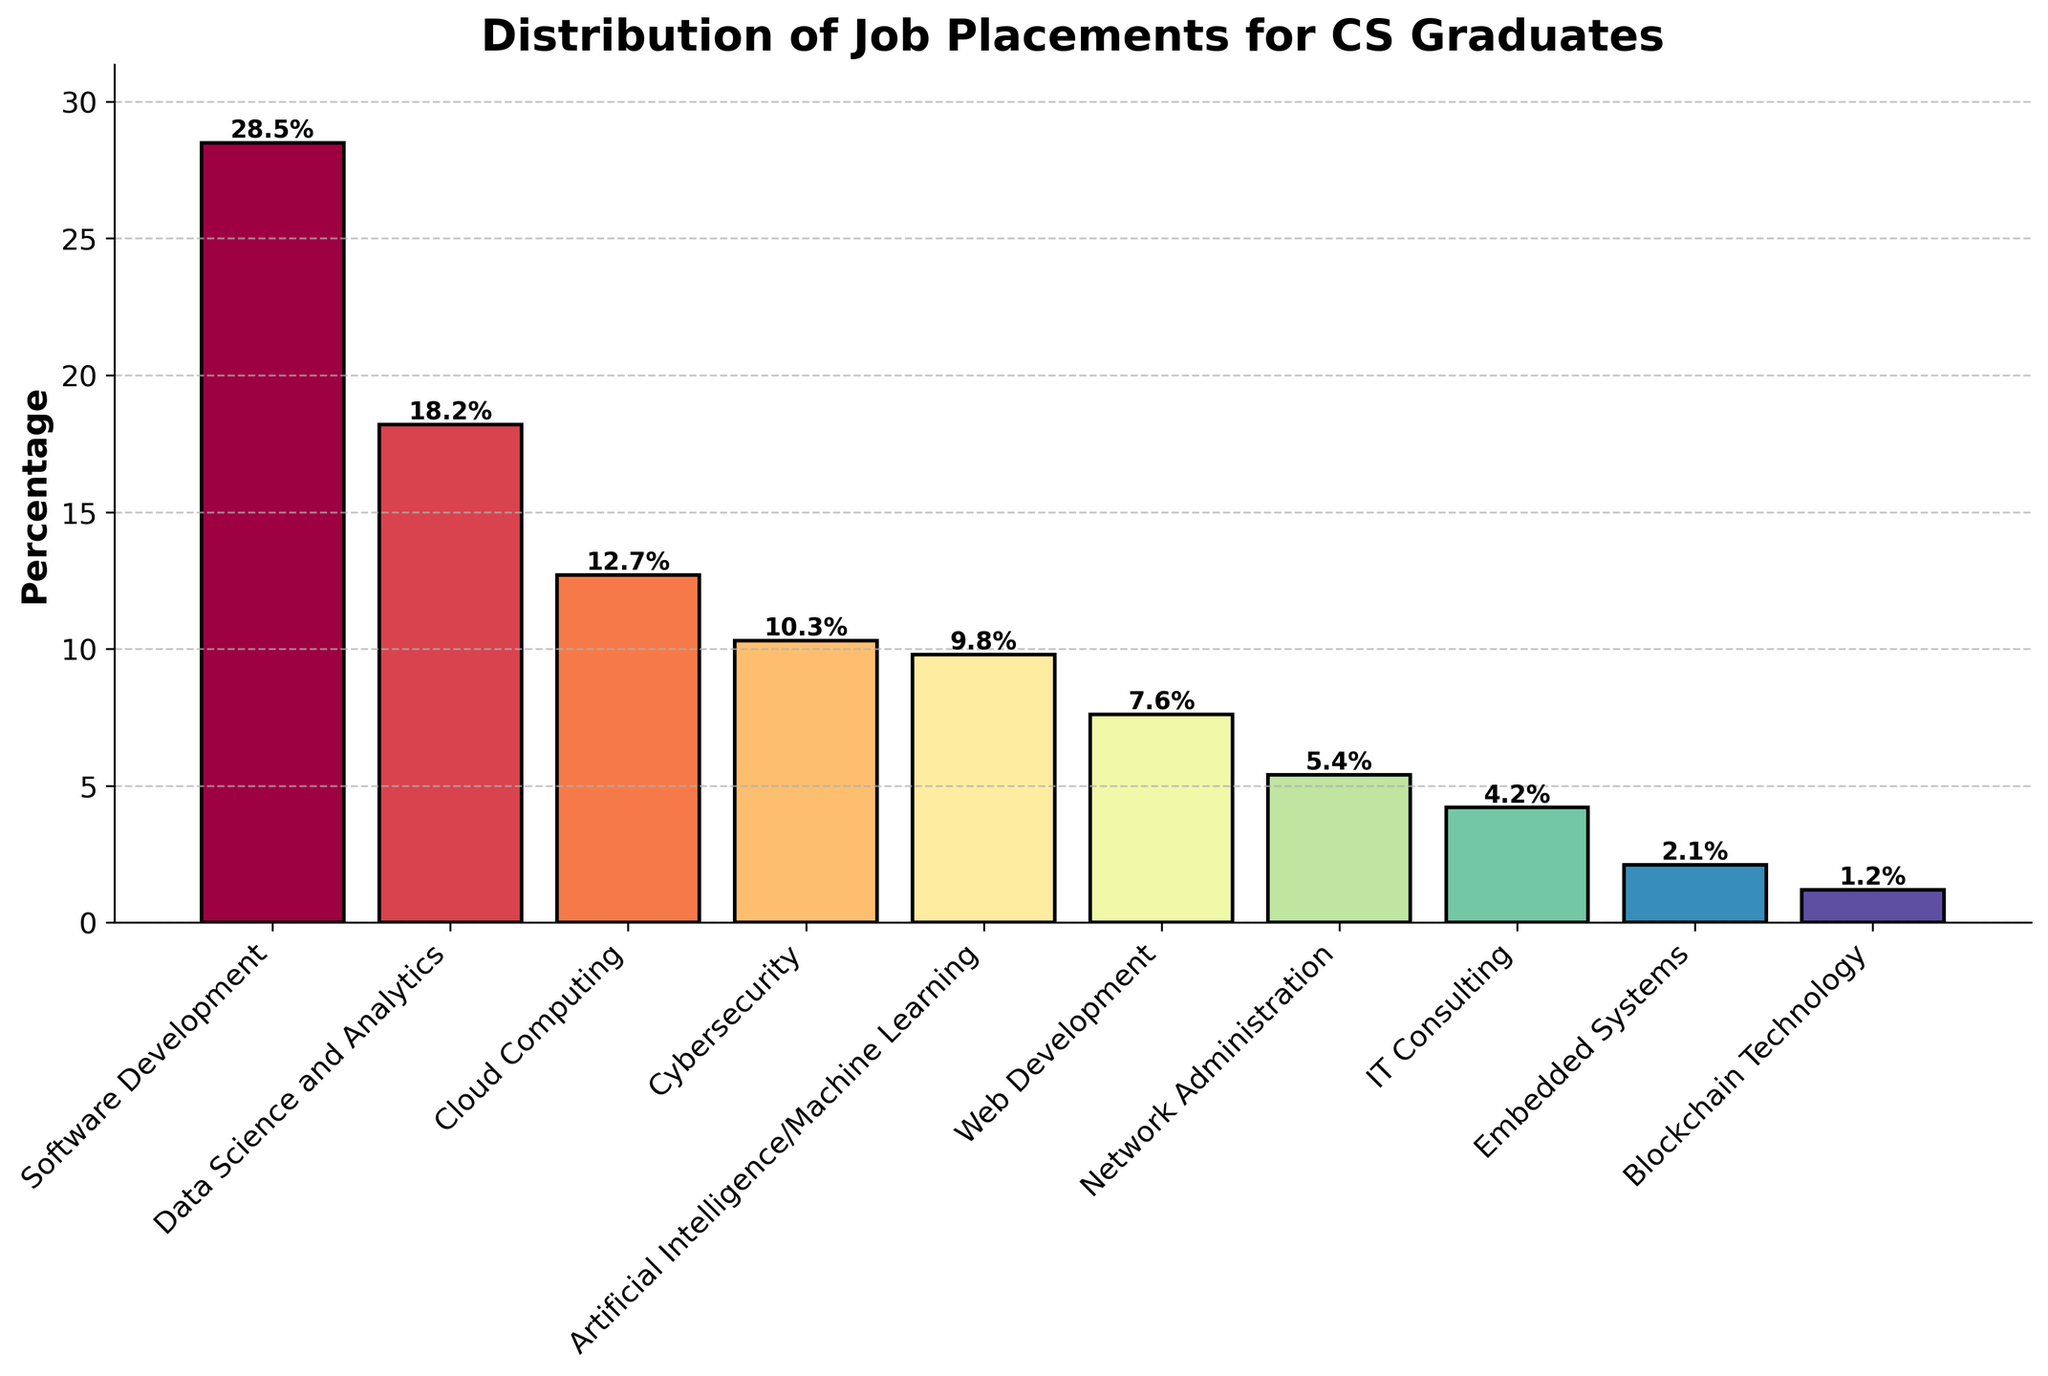What's the sector with the highest percentage of job placements? The sector with the highest percentage can be found by looking for the tallest bar in the chart. The tallest bar represents Software Development.
Answer: Software Development By how much does the percentage of job placements in Data Science and Analytics differ from that in Cloud Computing? The percentages of job placements in Data Science and Analytics and Cloud Computing are 18.2% and 12.7%, respectively. The difference can be calculated as 18.2% - 12.7% = 5.5%.
Answer: 5.5% Which sectors have a lower percentage of job placements than Web Development? Web Development has a percentage of 7.6%. We look for sectors with bars shorter than this: Network Administration (5.4%), IT Consulting (4.2%), Embedded Systems (2.1%), and Blockchain Technology (1.2%).
Answer: Network Administration, IT Consulting, Embedded Systems, Blockchain Technology What's the combined percentage of job placements for Artificial Intelligence/Machine Learning and Cybersecurity? The percentages are 9.8% for Artificial Intelligence/Machine Learning and 10.3% for Cybersecurity. The combined percentage is 9.8% + 10.3% = 20.1%.
Answer: 20.1% Is the percentage of job placements in IT Consulting more or less than half of the percentage in Cybersecurity? The percentage in Cybersecurity is 10.3%. Half of this value is 10.3% / 2 = 5.15%. The percentage in IT Consulting is 4.2%, which is less than 5.15%.
Answer: Less than Which sectors show single-digit percentages of job placements? Sectors with single-digit percentages are displayed with bars that have heights between 0% and 9.9%. The sectors are Artificial Intelligence/Machine Learning (9.8%), Web Development (7.6%), Network Administration (5.4%), IT Consulting (4.2%), Embedded Systems (2.1%), and Blockchain Technology (1.2%).
Answer: Artificial Intelligence/Machine Learning, Web Development, Network Administration, IT Consulting, Embedded Systems, Blockchain Technology Among the job placement sectors, which has the shortest bar in the figure? The shortest bar represents the sector with the lowest percentage. This is Blockchain Technology with 1.2%.
Answer: Blockchain Technology How much higher is the percentage of job placements in Software Development compared to Cybersecurity? The percentages are 28.5% for Software Development and 10.3% for Cybersecurity. The difference is 28.5% - 10.3% = 18.2%.
Answer: 18.2% If the percentages are grouped in ranges of 10%, how many sectors fall into each range? The ranges are 0%–10%, 10%–20%, and 20%–30%. The sectors are: 0%–10%: Artificial Intelligence/Machine Learning, Web Development, Network Administration, IT Consulting, Embedded Systems, Blockchain Technology (6 sectors), 10%–20%: Data Science and Analytics, Cloud Computing, Cybersecurity (3 sectors), 20%–30%: Software Development (1 sector).
Answer: 0%-10%: 6, 10%-20%: 3, 20%-30%: 1 Is the percentage of job placements in Cloud Computing closer to that in Cybersecurity or Data Science and Analytics? The percentages are Cloud Computing (12.7%), Cybersecurity (10.3%), Data Science and Analytics (18.2%). The differences are 12.7% - 10.3% = 2.4% and 18.2% - 12.7% = 5.5%. Cloud Computing is closer to Cybersecurity by 2.4%.
Answer: Cybersecurity 